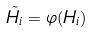<formula> <loc_0><loc_0><loc_500><loc_500>\tilde { H _ { i } } = \varphi ( H _ { i } )</formula> 